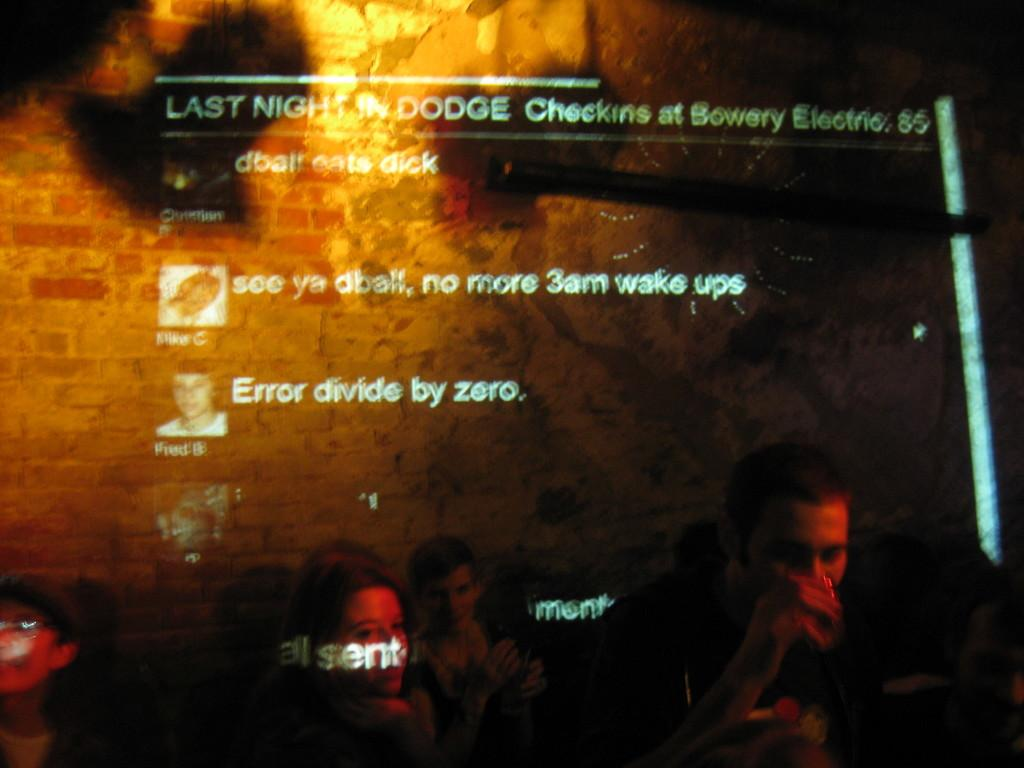What is happening with the people in the image? The people in the image are sitting. What can be seen in the background of the image? The background color is brown. Is there any text or writing present in the image? Yes, there is text or writing on the image. Can you tell me how many crows are sitting on the people's heads in the image? There are no crows present in the image; it only features a group of people sitting. What type of screw is being used to hold the text in place in the image? There is no screw visible in the image, as the text or writing is not physically attached to any object. 